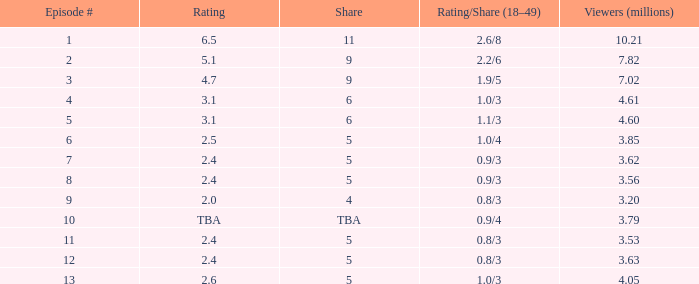With a rating/share of 1.1/3, what is the least million viewers an episode has had before reaching episode 5? None. 